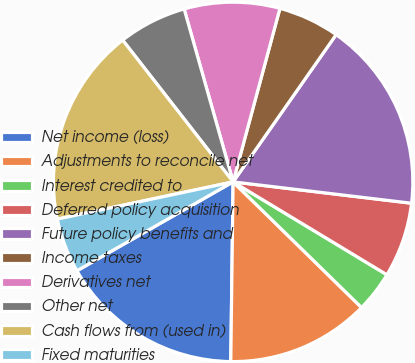Convert chart. <chart><loc_0><loc_0><loc_500><loc_500><pie_chart><fcel>Net income (loss)<fcel>Adjustments to reconcile net<fcel>Interest credited to<fcel>Deferred policy acquisition<fcel>Future policy benefits and<fcel>Income taxes<fcel>Derivatives net<fcel>Other net<fcel>Cash flows from (used in)<fcel>Fixed maturities<nl><fcel>16.56%<fcel>12.88%<fcel>3.68%<fcel>6.75%<fcel>17.18%<fcel>5.52%<fcel>8.59%<fcel>6.14%<fcel>17.79%<fcel>4.91%<nl></chart> 